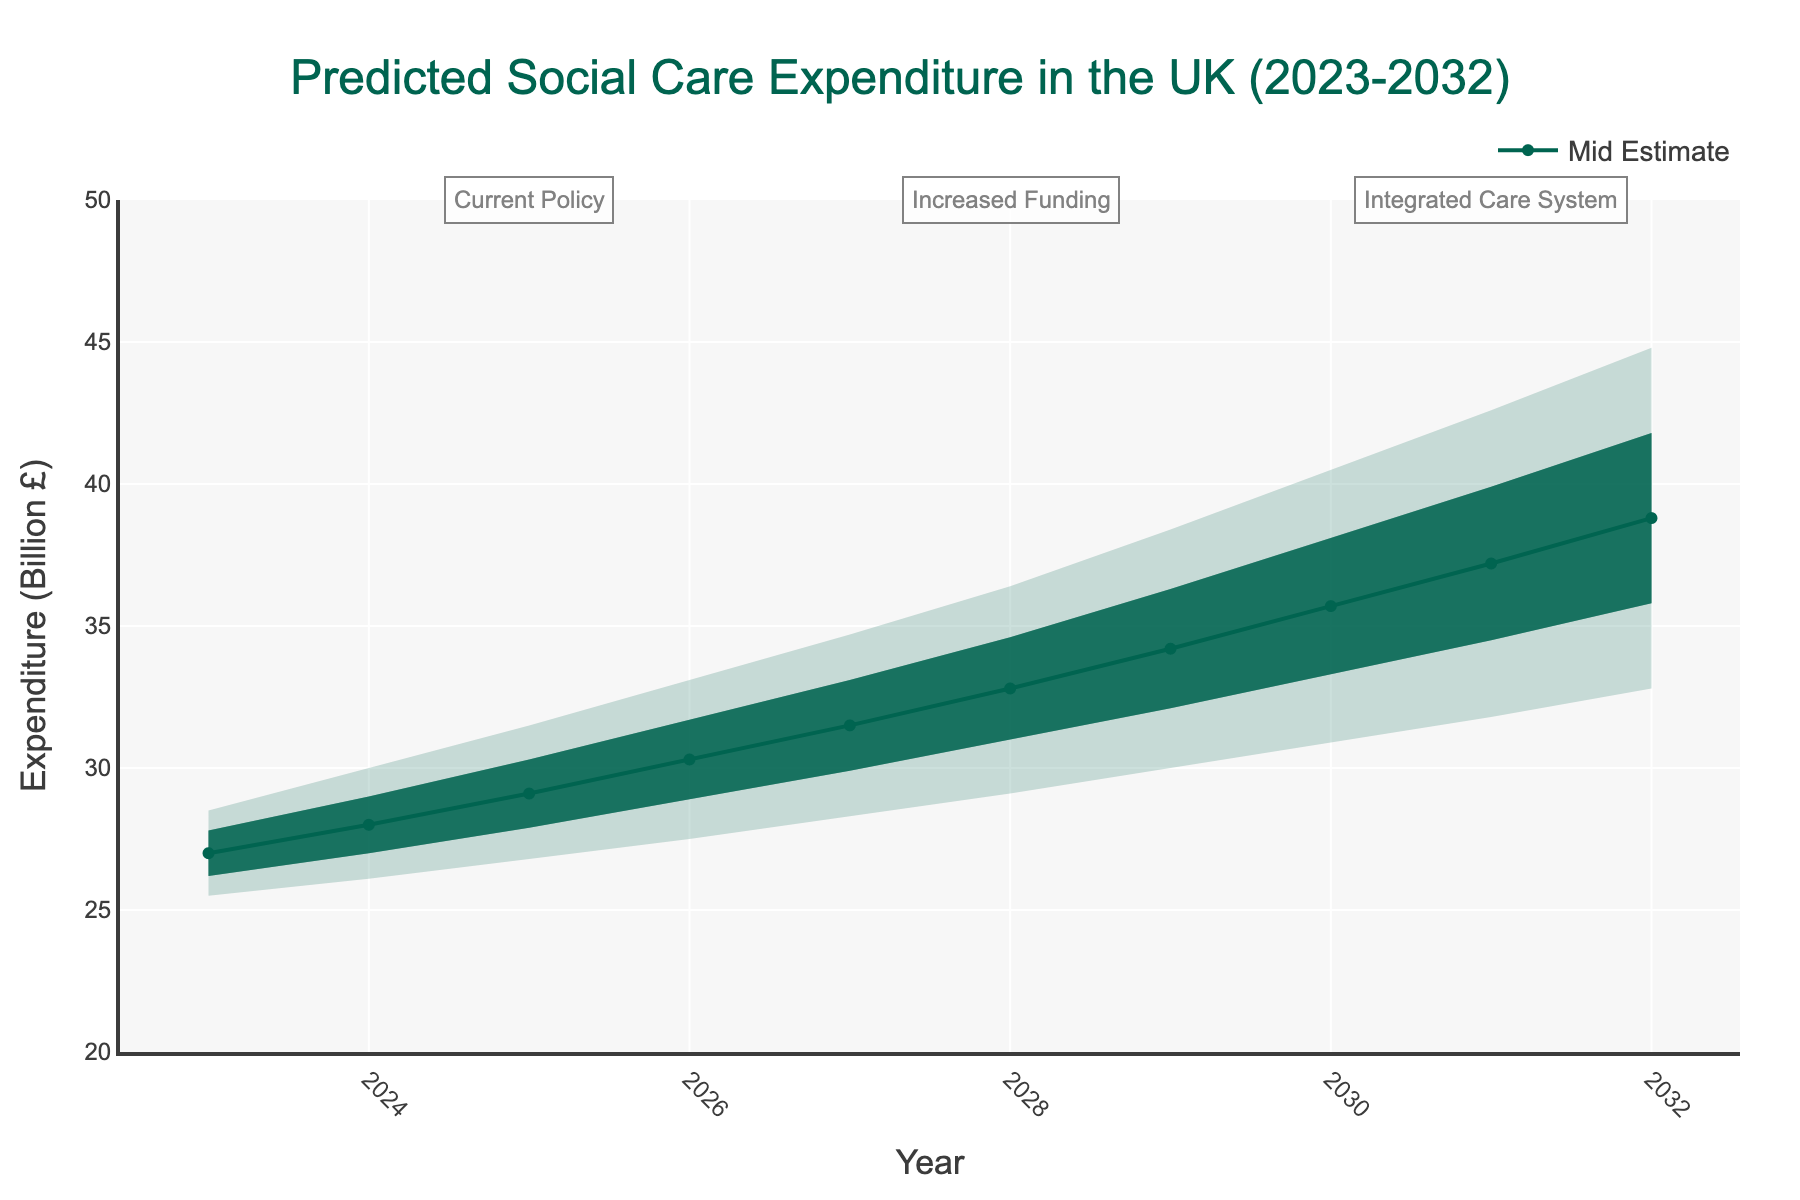What is the title of the chart? The title of the chart is located at the top and states the subject of the visual representation.
Answer: Predicted Social Care Expenditure in the UK (2023-2032) What is the range of the Y-axis? The Y-axis represents the expenditure in billions and its range is displayed from the minimum to the maximum value on the axis.
Answer: 20 to 50 Which year has the highest high estimate for social care expenditure? To find this, observe the highest value of the "High Estimate" line. It peaks at 44.8 in the year 2032.
Answer: 2032 What is the expenditure range for the year 2029 under the Increased Funding policy scenario? Look at the band for 2029, which falls under the Increased Funding policy; locate the minimum (Low Estimate: 30.0) and maximum (High Estimate: 38.4) expenditure.
Answer: 30.0 to 38.4 billion pounds What is the mid estimate of social care expenditure in 2026? Locate the year 2026 on the X-axis, then trace upward to the corresponding point on the "Mid Estimate" line.
Answer: 30.3 billion pounds How does the expenditure change from 2023 to 2032 according to the mid estimate? Observe the "Mid Estimate" line from the start (2023 at 27.0 billion pounds) to the end (2032 at 38.8 billion pounds) and calculate the difference.
Answer: Increases by 11.8 billion pounds Between which years does the policy scenario change from Current Policy to Increased Funding? Look for the annotations or shading changes indicating policy shifts. The scenario changes after 2026 to 2027.
Answer: 2026 to 2027 Which year shows the smallest difference between the high and low estimates? Evaluate the difference between the high and low expenditure bands for each year; 2023 has the smallest difference (28.5 - 25.5 = 3.0).
Answer: 2023 What is the average low estimate for the years listed under the "Integrated Care System" policy scenario? Identify the "Low Estimate" values for the years 2030, 2031, and 2032, add them, and divide by 3: (30.9 + 31.8 + 32.8) / 3.
Answer: 31.83 billion pounds Is there a year where the "Mid Estimate" line crosses the boundary of a policy scenario shift? Check if the "Mid Estimate" line intersects the vertical annotation lines indicating policy changes. It crosses from Current Policy to Increased Funding in 2027 and again into Integrated Care System in 2030.
Answer: Yes 